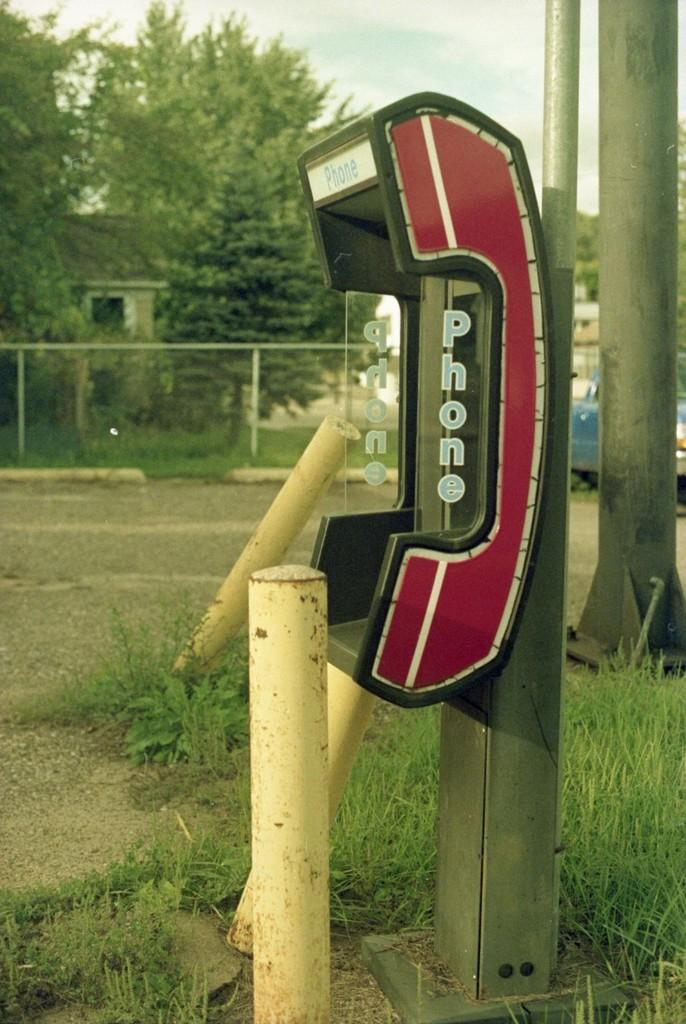What structure is present in the image? There is a phone booth in the image. What type of ground surface is visible in the image? Grass is visible on the ground. What type of barrier is present in the image? There is fencing in the image. What can be seen in the background of the image? There are poles, trees, and a house in the background of the image. Can you see any veins in the image? There are no veins visible in the image; it features a phone booth, grass, fencing, and background elements. What type of cactus is growing near the phone booth? There is no cactus present in the image. 